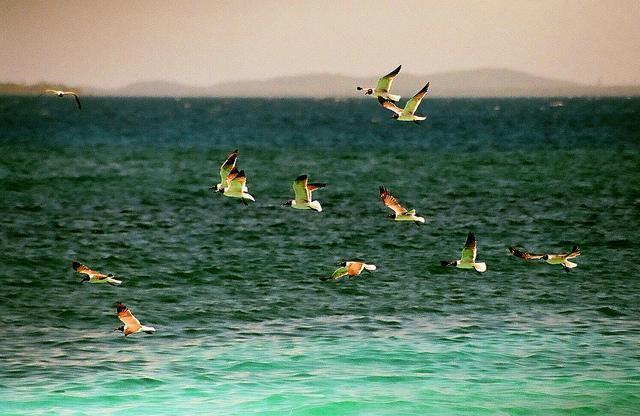How many people have beards?
Give a very brief answer. 0. 